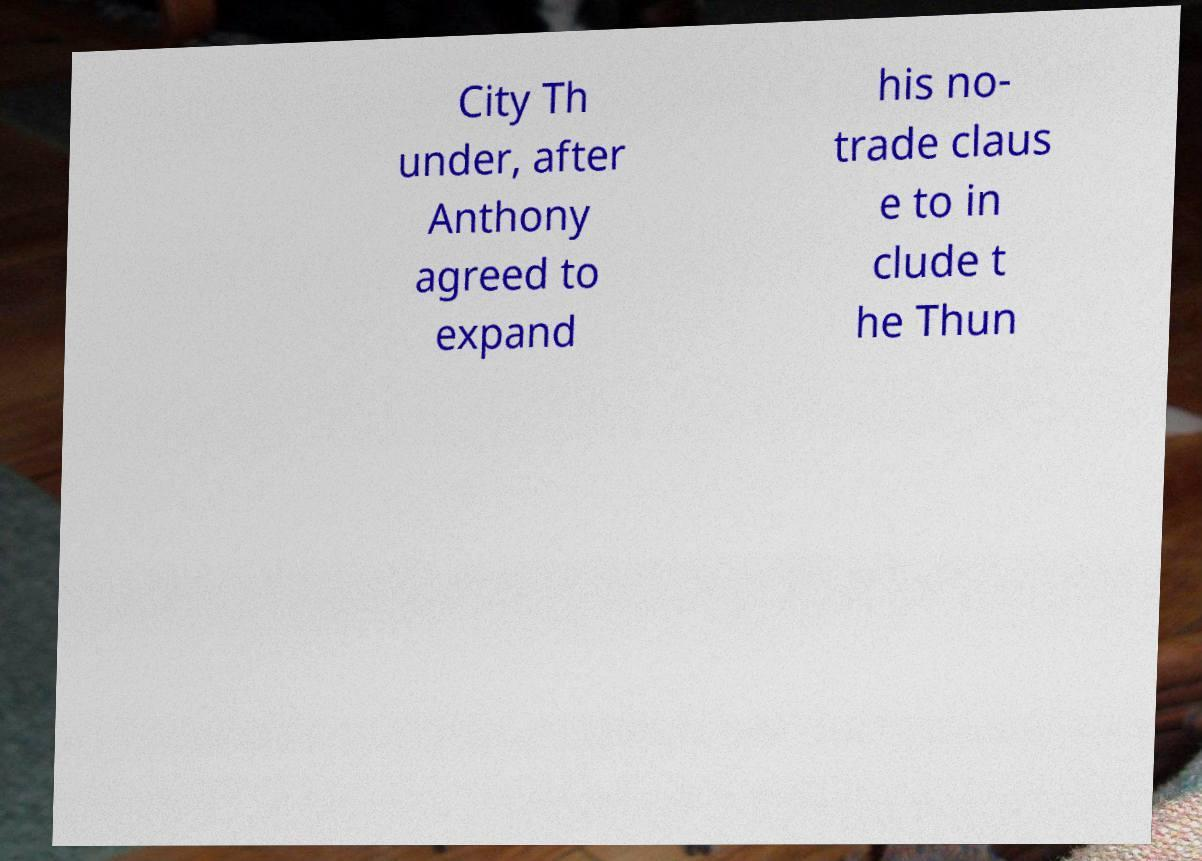For documentation purposes, I need the text within this image transcribed. Could you provide that? City Th under, after Anthony agreed to expand his no- trade claus e to in clude t he Thun 